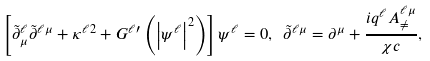Convert formula to latex. <formula><loc_0><loc_0><loc_500><loc_500>\left [ \tilde { \partial } _ { \mu } ^ { \ell } \tilde { \partial } ^ { \ell \mu } + \kappa ^ { \ell 2 } + G ^ { \ell \prime } \left ( \left | \psi ^ { \ell } \right | ^ { 2 } \right ) \right ] \psi ^ { \ell } = 0 , \ \tilde { \partial } ^ { \ell \mu } = \partial ^ { \mu } + \frac { i q ^ { \ell } A _ { \neq } ^ { \ell \mu } } { \chi c } ,</formula> 